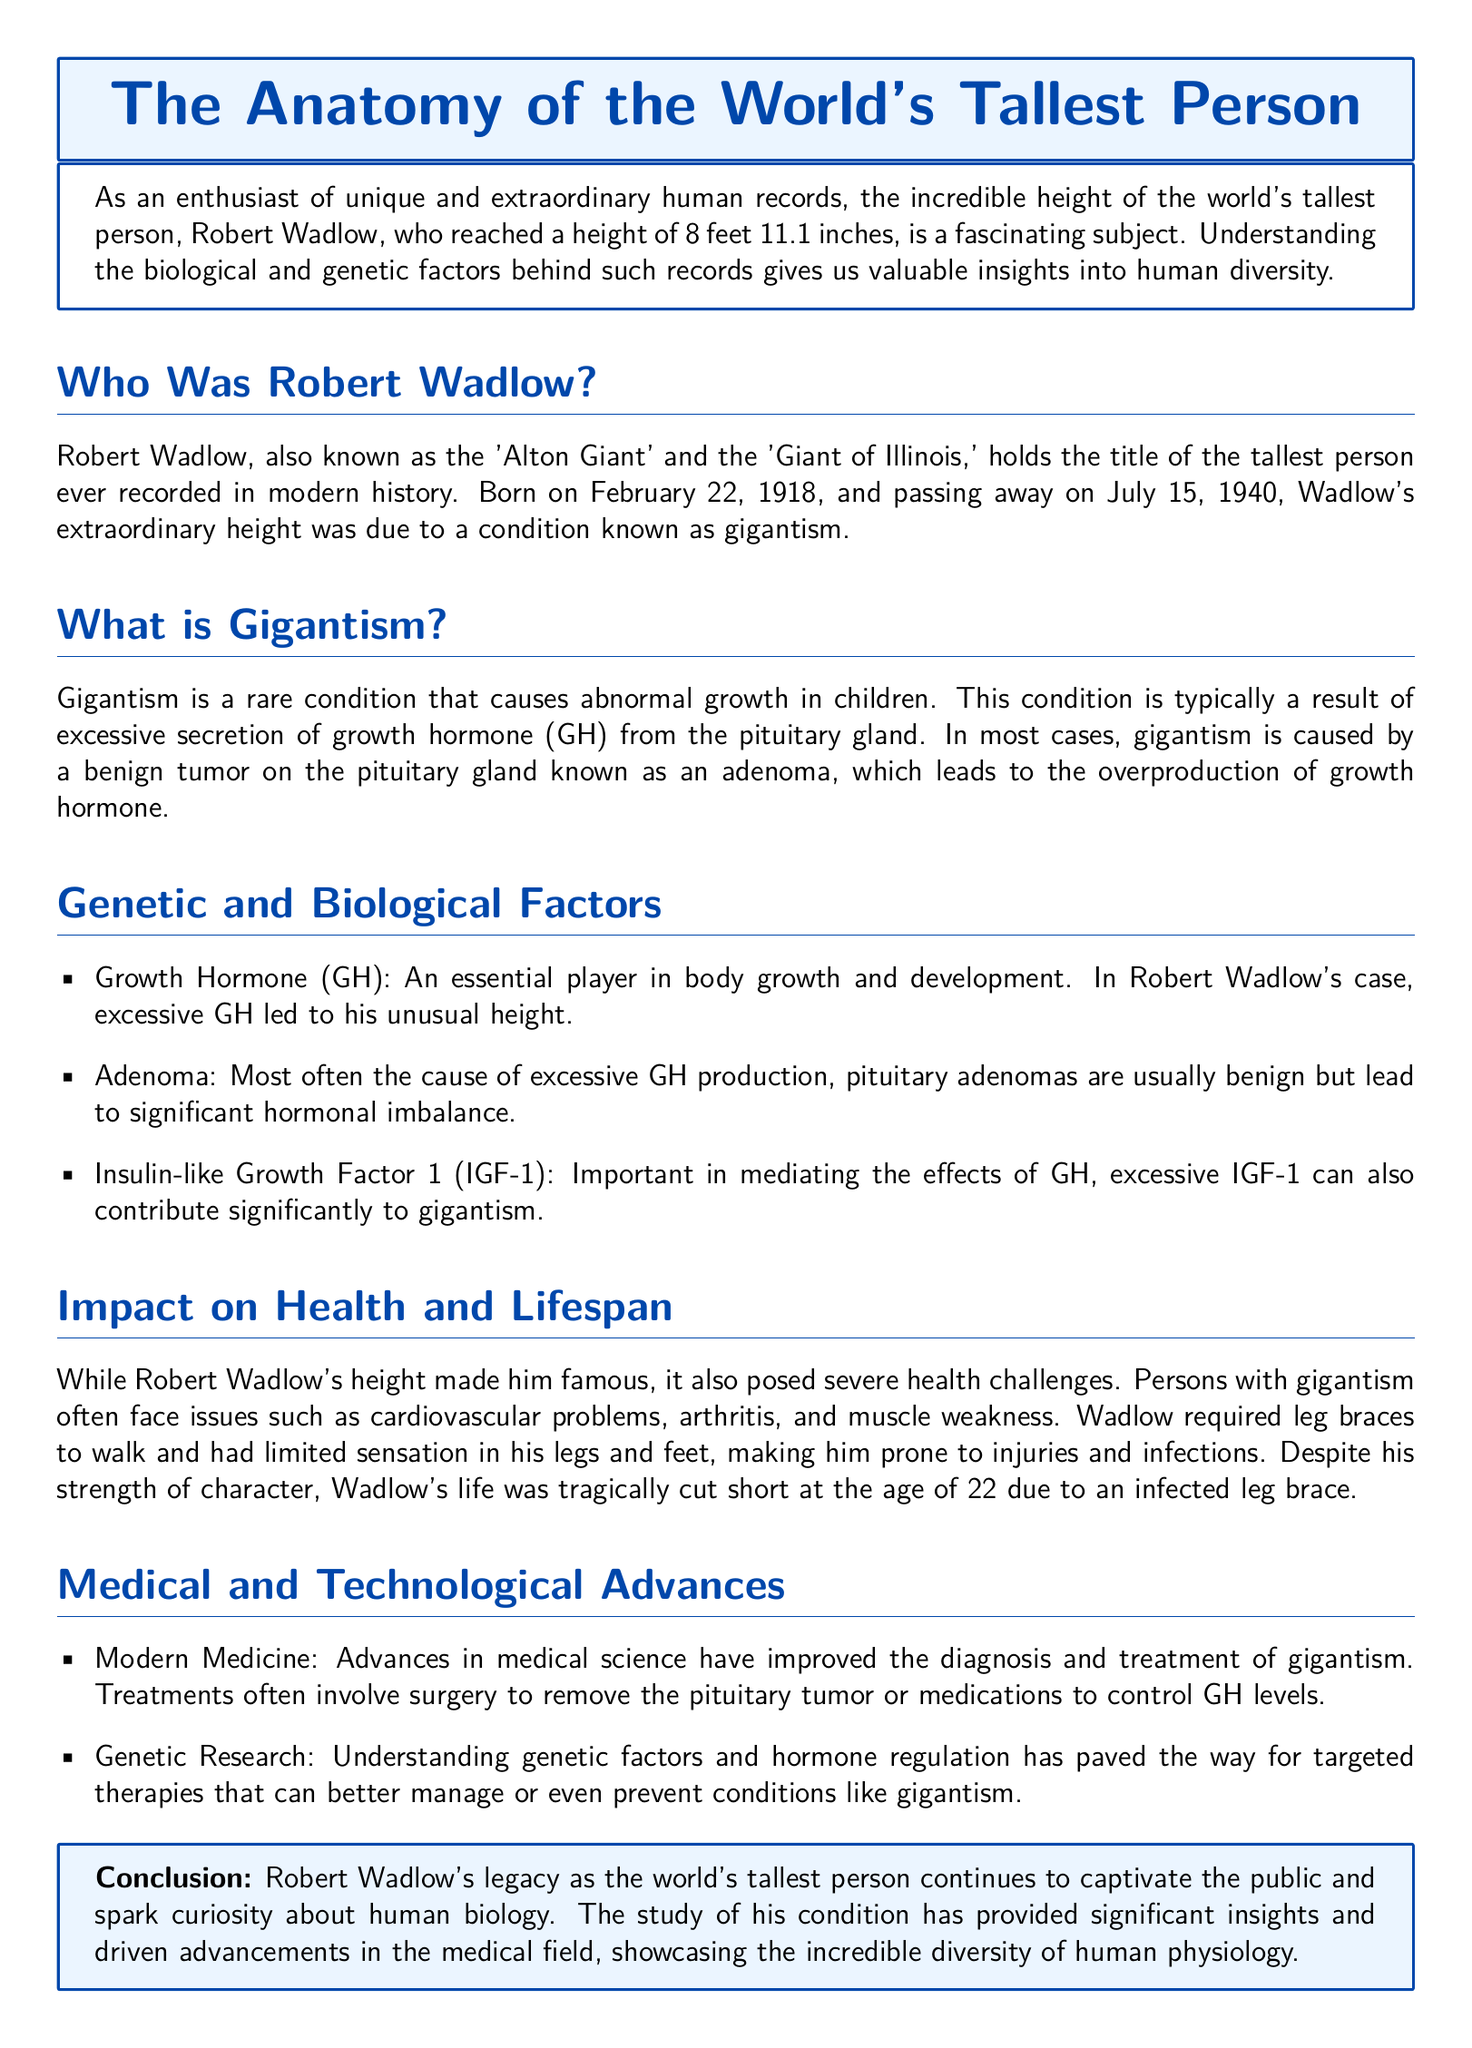Who was the world's tallest person? The document states that Robert Wadlow holds the title of the tallest person ever recorded in modern history.
Answer: Robert Wadlow What condition caused Robert Wadlow's height? The document specifies that Wadlow's extraordinary height was due to a condition known as gigantism.
Answer: Gigantism What is a common cause of gigantism? The document informs that gigantism is caused by excessive secretion of growth hormone from the pituitary gland, often due to a benign tumor called adenoma.
Answer: Adenoma How tall was Robert Wadlow? The document mentions that Robert Wadlow reached a height of 8 feet 11.1 inches.
Answer: 8 feet 11.1 inches What are two health challenges associated with gigantism? The document lists several health challenges, with cardiovascular problems and arthritis mentioned specifically.
Answer: Cardiovascular problems, arthritis How has modern medicine improved the treatment of gigantism? The document explains that advances have led to improved diagnosis and treatments, such as surgery to remove the pituitary tumor.
Answer: Surgery What hormone mediates the effects of growth hormone? The document indicates that Insulin-like Growth Factor 1 is important in mediating the effects of growth hormone.
Answer: Insulin-like Growth Factor 1 At what age did Robert Wadlow pass away? The document states that Robert Wadlow passed away at the age of 22.
Answer: 22 What legacy did Robert Wadlow leave behind? The document concludes that his legacy continues to captivate the public and spark curiosity about human biology.
Answer: Curiosity about human biology 